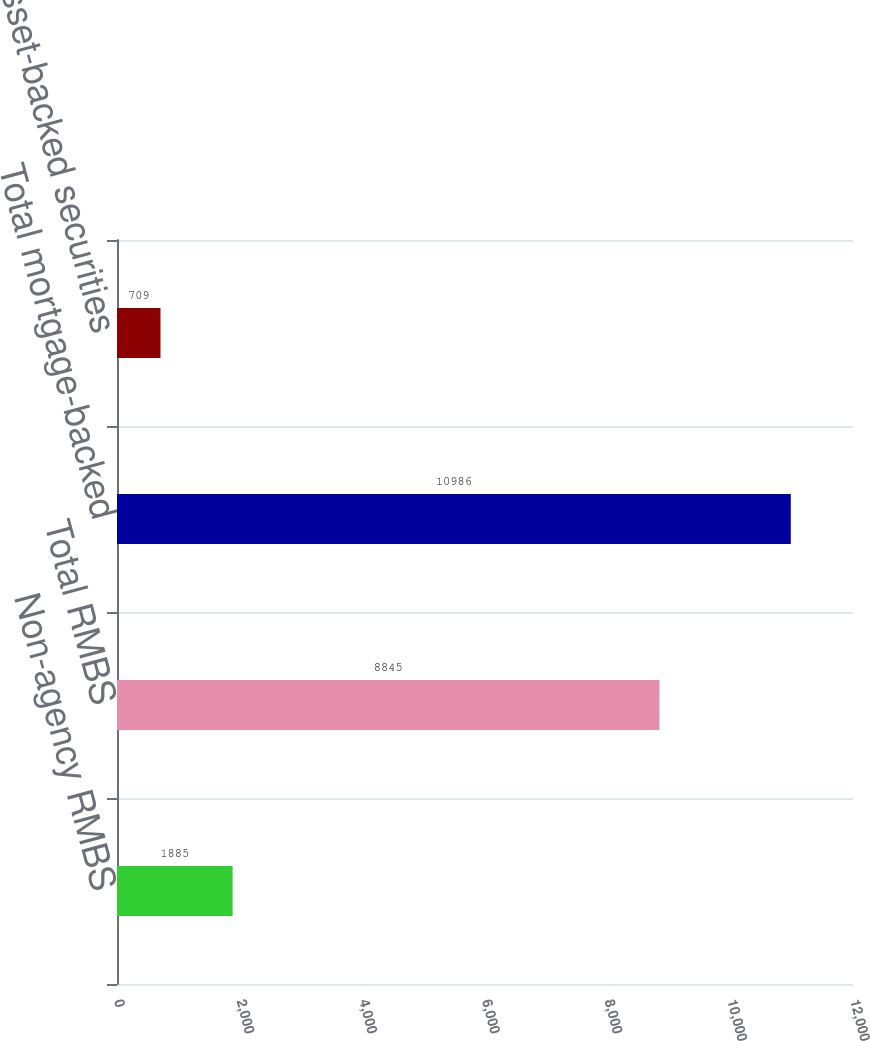<chart> <loc_0><loc_0><loc_500><loc_500><bar_chart><fcel>Non-agency RMBS<fcel>Total RMBS<fcel>Total mortgage-backed<fcel>Total asset-backed securities<nl><fcel>1885<fcel>8845<fcel>10986<fcel>709<nl></chart> 